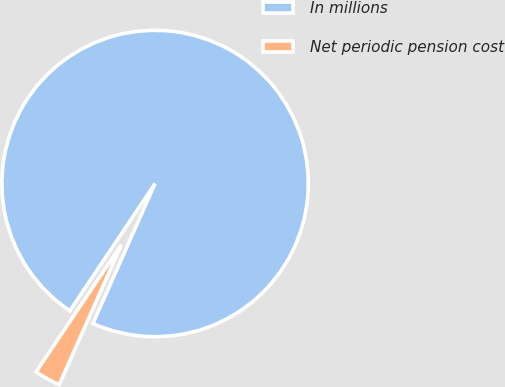Convert chart. <chart><loc_0><loc_0><loc_500><loc_500><pie_chart><fcel>In millions<fcel>Net periodic pension cost<nl><fcel>97.25%<fcel>2.75%<nl></chart> 